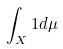<formula> <loc_0><loc_0><loc_500><loc_500>\int _ { X } 1 d \mu</formula> 